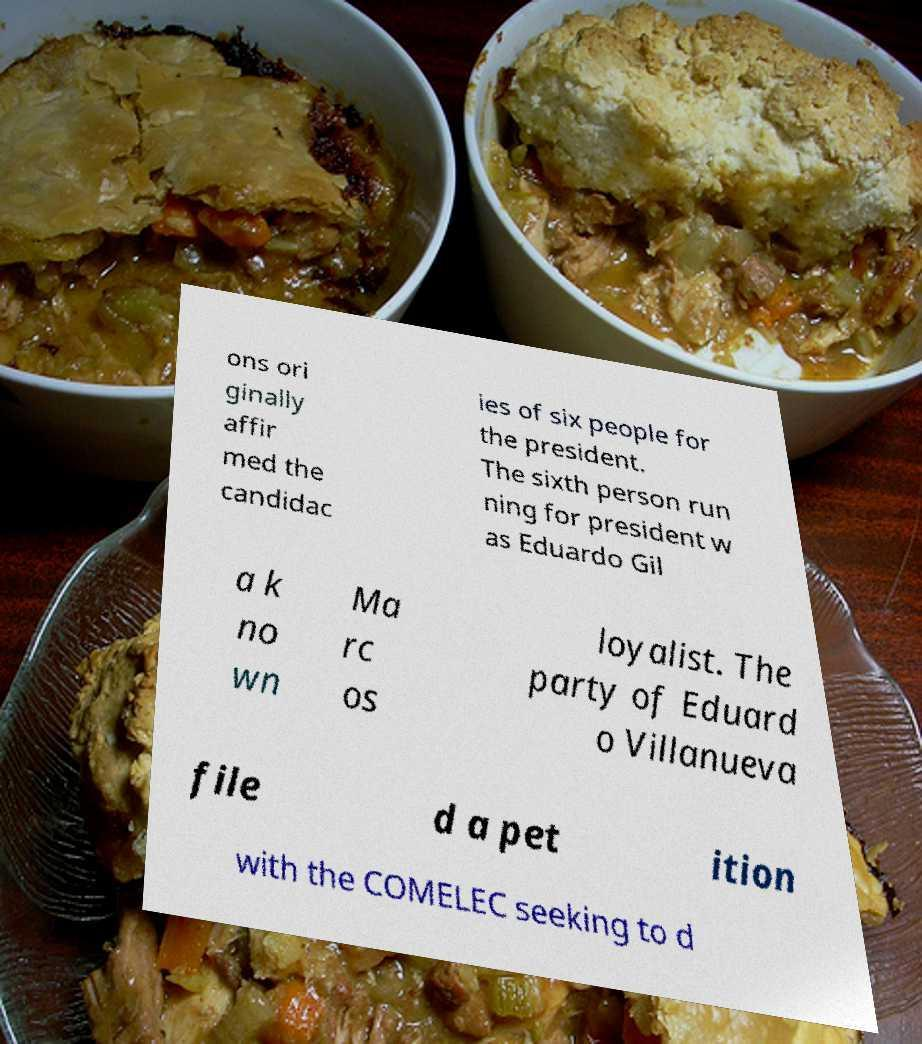Could you extract and type out the text from this image? ons ori ginally affir med the candidac ies of six people for the president. The sixth person run ning for president w as Eduardo Gil a k no wn Ma rc os loyalist. The party of Eduard o Villanueva file d a pet ition with the COMELEC seeking to d 